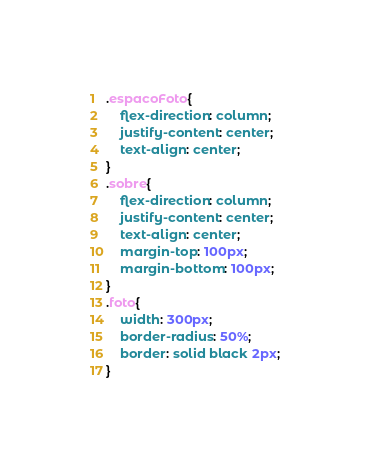<code> <loc_0><loc_0><loc_500><loc_500><_CSS_>
.espacoFoto{
    flex-direction: column;
    justify-content: center;
    text-align: center;
}
.sobre{
    flex-direction: column;
    justify-content: center;
    text-align: center;
    margin-top: 100px;
    margin-bottom: 100px;
}
.foto{
    width: 300px;
    border-radius: 50%;
    border: solid black 2px;
}</code> 